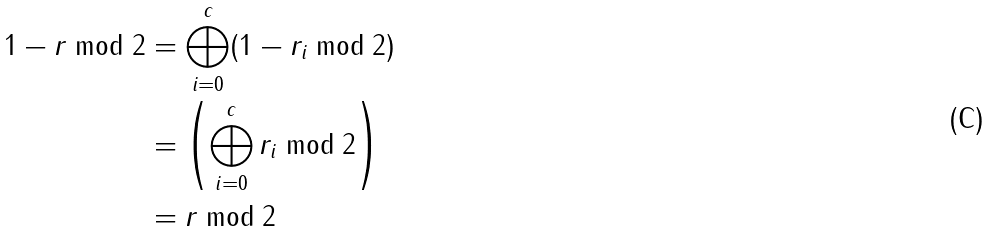<formula> <loc_0><loc_0><loc_500><loc_500>1 - r \bmod 2 & = \bigoplus _ { i = 0 } ^ { c } ( 1 - r _ { i } \bmod 2 ) \\ & = \left ( \bigoplus _ { i = 0 } ^ { c } r _ { i } \bmod 2 \right ) \\ & = r \bmod 2</formula> 